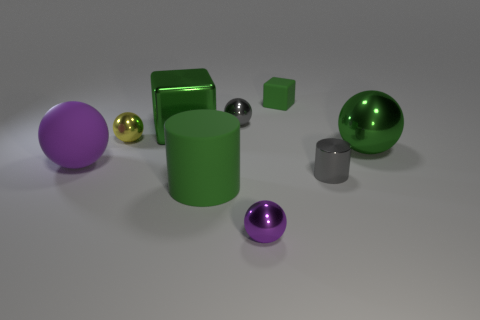Subtract all small gray spheres. How many spheres are left? 4 Subtract all gray balls. How many balls are left? 4 Subtract all red balls. Subtract all blue cylinders. How many balls are left? 5 Add 1 metallic cubes. How many objects exist? 10 Subtract all cylinders. How many objects are left? 7 Add 4 shiny cylinders. How many shiny cylinders are left? 5 Add 9 green metal cubes. How many green metal cubes exist? 10 Subtract 0 purple cubes. How many objects are left? 9 Subtract all tiny green things. Subtract all large red shiny cylinders. How many objects are left? 8 